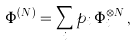<formula> <loc_0><loc_0><loc_500><loc_500>\Phi ^ { ( N ) } = { \sum _ { i } p _ { i } \, \Phi _ { i } ^ { \otimes N } } \, ,</formula> 